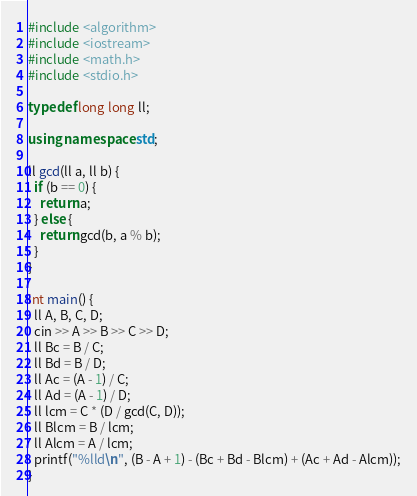<code> <loc_0><loc_0><loc_500><loc_500><_C++_>#include <algorithm>
#include <iostream>
#include <math.h>
#include <stdio.h>

typedef long long ll;

using namespace std;

ll gcd(ll a, ll b) {
  if (b == 0) {
    return a;
  } else {
    return gcd(b, a % b);
  }
}

int main() {
  ll A, B, C, D;
  cin >> A >> B >> C >> D;
  ll Bc = B / C;
  ll Bd = B / D;
  ll Ac = (A - 1) / C;
  ll Ad = (A - 1) / D;
  ll lcm = C * (D / gcd(C, D));
  ll Blcm = B / lcm;
  ll Alcm = A / lcm;
  printf("%lld\n", (B - A + 1) - (Bc + Bd - Blcm) + (Ac + Ad - Alcm));
}</code> 